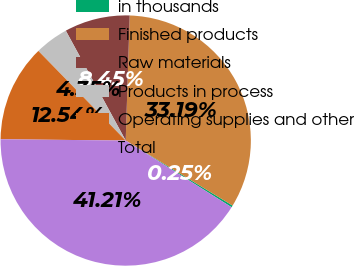Convert chart to OTSL. <chart><loc_0><loc_0><loc_500><loc_500><pie_chart><fcel>in thousands<fcel>Finished products<fcel>Raw materials<fcel>Products in process<fcel>Operating supplies and other<fcel>Total<nl><fcel>0.25%<fcel>33.19%<fcel>8.45%<fcel>4.35%<fcel>12.54%<fcel>41.21%<nl></chart> 